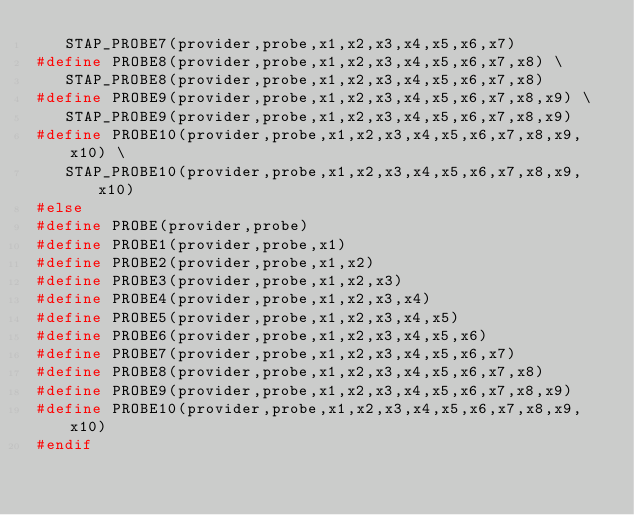<code> <loc_0><loc_0><loc_500><loc_500><_C_>   STAP_PROBE7(provider,probe,x1,x2,x3,x4,x5,x6,x7)
#define PROBE8(provider,probe,x1,x2,x3,x4,x5,x6,x7,x8) \
   STAP_PROBE8(provider,probe,x1,x2,x3,x4,x5,x6,x7,x8)
#define PROBE9(provider,probe,x1,x2,x3,x4,x5,x6,x7,x8,x9) \
   STAP_PROBE9(provider,probe,x1,x2,x3,x4,x5,x6,x7,x8,x9)
#define PROBE10(provider,probe,x1,x2,x3,x4,x5,x6,x7,x8,x9,x10) \
   STAP_PROBE10(provider,probe,x1,x2,x3,x4,x5,x6,x7,x8,x9,x10)
#else
#define PROBE(provider,probe)
#define PROBE1(provider,probe,x1)
#define PROBE2(provider,probe,x1,x2)
#define PROBE3(provider,probe,x1,x2,x3)
#define PROBE4(provider,probe,x1,x2,x3,x4)
#define PROBE5(provider,probe,x1,x2,x3,x4,x5)
#define PROBE6(provider,probe,x1,x2,x3,x4,x5,x6)
#define PROBE7(provider,probe,x1,x2,x3,x4,x5,x6,x7)
#define PROBE8(provider,probe,x1,x2,x3,x4,x5,x6,x7,x8)
#define PROBE9(provider,probe,x1,x2,x3,x4,x5,x6,x7,x8,x9)
#define PROBE10(provider,probe,x1,x2,x3,x4,x5,x6,x7,x8,x9,x10)
#endif

</code> 